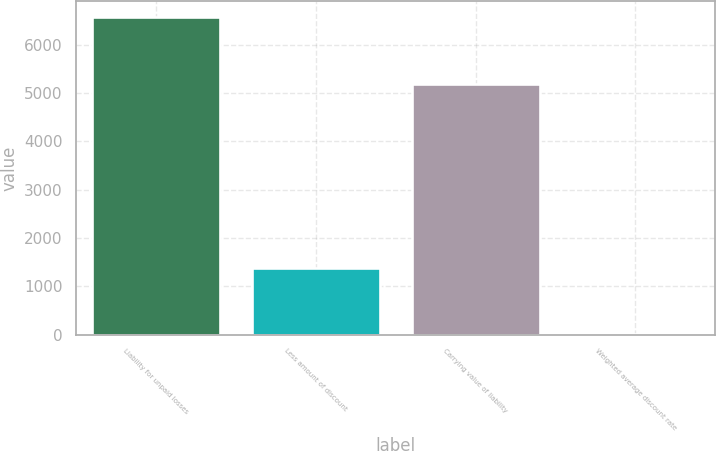Convert chart. <chart><loc_0><loc_0><loc_500><loc_500><bar_chart><fcel>Liability for unpaid losses<fcel>Less amount of discount<fcel>Carrying value of liability<fcel>Weighted average discount rate<nl><fcel>6565<fcel>1382<fcel>5183<fcel>4.4<nl></chart> 